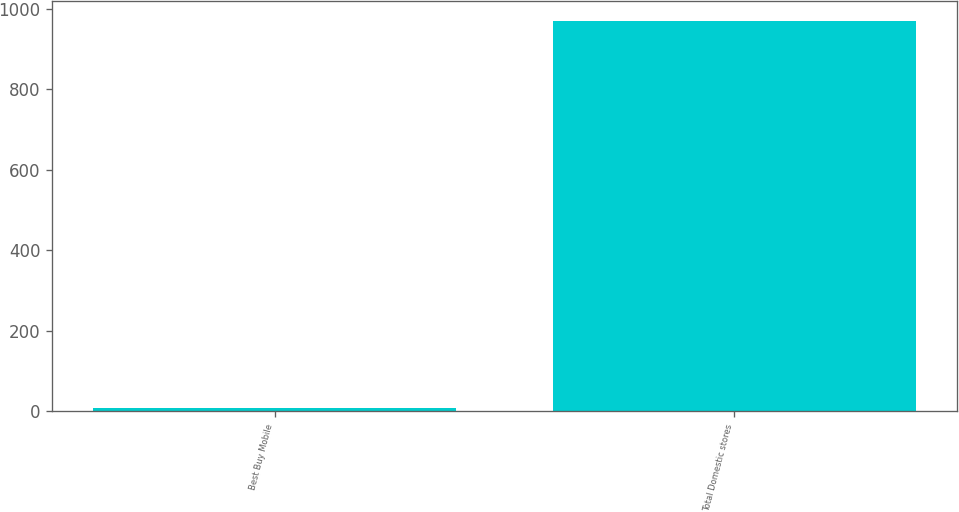<chart> <loc_0><loc_0><loc_500><loc_500><bar_chart><fcel>Best Buy Mobile<fcel>Total Domestic stores<nl><fcel>9<fcel>971<nl></chart> 